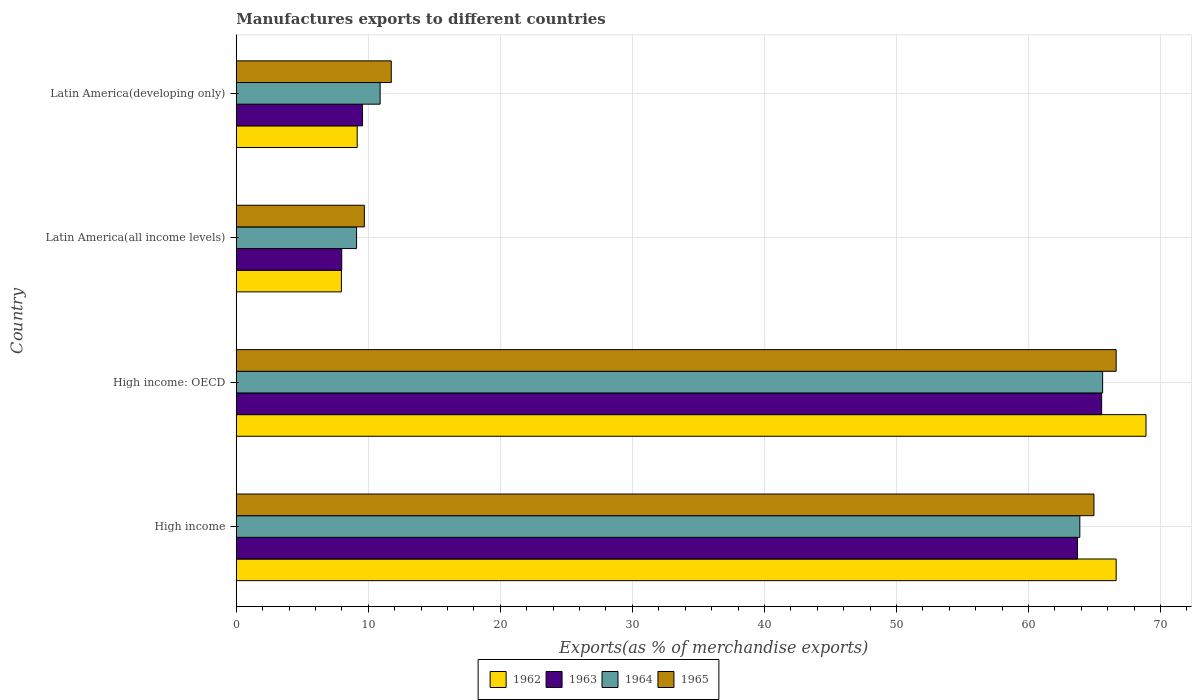How many different coloured bars are there?
Your answer should be very brief. 4. How many groups of bars are there?
Give a very brief answer. 4. How many bars are there on the 4th tick from the top?
Give a very brief answer. 4. How many bars are there on the 2nd tick from the bottom?
Keep it short and to the point. 4. What is the label of the 3rd group of bars from the top?
Provide a succinct answer. High income: OECD. In how many cases, is the number of bars for a given country not equal to the number of legend labels?
Offer a very short reply. 0. What is the percentage of exports to different countries in 1965 in Latin America(all income levels)?
Provide a succinct answer. 9.7. Across all countries, what is the maximum percentage of exports to different countries in 1962?
Provide a succinct answer. 68.9. Across all countries, what is the minimum percentage of exports to different countries in 1965?
Keep it short and to the point. 9.7. In which country was the percentage of exports to different countries in 1965 maximum?
Provide a succinct answer. High income: OECD. In which country was the percentage of exports to different countries in 1963 minimum?
Provide a short and direct response. Latin America(all income levels). What is the total percentage of exports to different countries in 1964 in the graph?
Provide a short and direct response. 149.51. What is the difference between the percentage of exports to different countries in 1962 in High income: OECD and that in Latin America(all income levels)?
Keep it short and to the point. 60.93. What is the difference between the percentage of exports to different countries in 1962 in Latin America(all income levels) and the percentage of exports to different countries in 1963 in High income: OECD?
Make the answer very short. -57.57. What is the average percentage of exports to different countries in 1964 per country?
Give a very brief answer. 37.38. What is the difference between the percentage of exports to different countries in 1964 and percentage of exports to different countries in 1965 in Latin America(all income levels)?
Your answer should be compact. -0.59. What is the ratio of the percentage of exports to different countries in 1965 in Latin America(all income levels) to that in Latin America(developing only)?
Make the answer very short. 0.83. What is the difference between the highest and the second highest percentage of exports to different countries in 1964?
Give a very brief answer. 1.73. What is the difference between the highest and the lowest percentage of exports to different countries in 1962?
Provide a succinct answer. 60.93. In how many countries, is the percentage of exports to different countries in 1964 greater than the average percentage of exports to different countries in 1964 taken over all countries?
Your answer should be very brief. 2. Is the sum of the percentage of exports to different countries in 1964 in High income and Latin America(all income levels) greater than the maximum percentage of exports to different countries in 1965 across all countries?
Provide a succinct answer. Yes. Is it the case that in every country, the sum of the percentage of exports to different countries in 1964 and percentage of exports to different countries in 1963 is greater than the sum of percentage of exports to different countries in 1962 and percentage of exports to different countries in 1965?
Provide a succinct answer. No. What does the 2nd bar from the top in High income: OECD represents?
Offer a very short reply. 1964. What does the 2nd bar from the bottom in High income: OECD represents?
Your response must be concise. 1963. How many countries are there in the graph?
Make the answer very short. 4. Are the values on the major ticks of X-axis written in scientific E-notation?
Provide a short and direct response. No. How many legend labels are there?
Keep it short and to the point. 4. What is the title of the graph?
Offer a terse response. Manufactures exports to different countries. Does "2000" appear as one of the legend labels in the graph?
Your response must be concise. No. What is the label or title of the X-axis?
Your answer should be compact. Exports(as % of merchandise exports). What is the Exports(as % of merchandise exports) of 1962 in High income?
Offer a terse response. 66.64. What is the Exports(as % of merchandise exports) in 1963 in High income?
Your answer should be compact. 63.71. What is the Exports(as % of merchandise exports) in 1964 in High income?
Ensure brevity in your answer.  63.89. What is the Exports(as % of merchandise exports) in 1965 in High income?
Your answer should be compact. 64.96. What is the Exports(as % of merchandise exports) of 1962 in High income: OECD?
Your response must be concise. 68.9. What is the Exports(as % of merchandise exports) in 1963 in High income: OECD?
Your answer should be compact. 65.54. What is the Exports(as % of merchandise exports) of 1964 in High income: OECD?
Offer a very short reply. 65.61. What is the Exports(as % of merchandise exports) in 1965 in High income: OECD?
Offer a terse response. 66.64. What is the Exports(as % of merchandise exports) of 1962 in Latin America(all income levels)?
Your answer should be very brief. 7.96. What is the Exports(as % of merchandise exports) of 1963 in Latin America(all income levels)?
Make the answer very short. 7.99. What is the Exports(as % of merchandise exports) in 1964 in Latin America(all income levels)?
Your response must be concise. 9.11. What is the Exports(as % of merchandise exports) of 1965 in Latin America(all income levels)?
Give a very brief answer. 9.7. What is the Exports(as % of merchandise exports) of 1962 in Latin America(developing only)?
Provide a succinct answer. 9.16. What is the Exports(as % of merchandise exports) in 1963 in Latin America(developing only)?
Ensure brevity in your answer.  9.56. What is the Exports(as % of merchandise exports) in 1964 in Latin America(developing only)?
Offer a terse response. 10.9. What is the Exports(as % of merchandise exports) in 1965 in Latin America(developing only)?
Give a very brief answer. 11.74. Across all countries, what is the maximum Exports(as % of merchandise exports) of 1962?
Keep it short and to the point. 68.9. Across all countries, what is the maximum Exports(as % of merchandise exports) in 1963?
Give a very brief answer. 65.54. Across all countries, what is the maximum Exports(as % of merchandise exports) in 1964?
Your answer should be compact. 65.61. Across all countries, what is the maximum Exports(as % of merchandise exports) in 1965?
Your answer should be compact. 66.64. Across all countries, what is the minimum Exports(as % of merchandise exports) of 1962?
Your response must be concise. 7.96. Across all countries, what is the minimum Exports(as % of merchandise exports) in 1963?
Keep it short and to the point. 7.99. Across all countries, what is the minimum Exports(as % of merchandise exports) in 1964?
Your answer should be very brief. 9.11. Across all countries, what is the minimum Exports(as % of merchandise exports) of 1965?
Your response must be concise. 9.7. What is the total Exports(as % of merchandise exports) of 1962 in the graph?
Your response must be concise. 152.66. What is the total Exports(as % of merchandise exports) in 1963 in the graph?
Keep it short and to the point. 146.8. What is the total Exports(as % of merchandise exports) in 1964 in the graph?
Keep it short and to the point. 149.51. What is the total Exports(as % of merchandise exports) in 1965 in the graph?
Offer a very short reply. 153.03. What is the difference between the Exports(as % of merchandise exports) of 1962 in High income and that in High income: OECD?
Offer a terse response. -2.26. What is the difference between the Exports(as % of merchandise exports) in 1963 in High income and that in High income: OECD?
Your answer should be compact. -1.83. What is the difference between the Exports(as % of merchandise exports) in 1964 in High income and that in High income: OECD?
Offer a very short reply. -1.73. What is the difference between the Exports(as % of merchandise exports) of 1965 in High income and that in High income: OECD?
Ensure brevity in your answer.  -1.68. What is the difference between the Exports(as % of merchandise exports) of 1962 in High income and that in Latin America(all income levels)?
Provide a succinct answer. 58.68. What is the difference between the Exports(as % of merchandise exports) in 1963 in High income and that in Latin America(all income levels)?
Ensure brevity in your answer.  55.72. What is the difference between the Exports(as % of merchandise exports) in 1964 in High income and that in Latin America(all income levels)?
Your response must be concise. 54.78. What is the difference between the Exports(as % of merchandise exports) in 1965 in High income and that in Latin America(all income levels)?
Your answer should be very brief. 55.25. What is the difference between the Exports(as % of merchandise exports) in 1962 in High income and that in Latin America(developing only)?
Offer a terse response. 57.48. What is the difference between the Exports(as % of merchandise exports) in 1963 in High income and that in Latin America(developing only)?
Offer a terse response. 54.15. What is the difference between the Exports(as % of merchandise exports) in 1964 in High income and that in Latin America(developing only)?
Offer a very short reply. 52.99. What is the difference between the Exports(as % of merchandise exports) in 1965 in High income and that in Latin America(developing only)?
Your response must be concise. 53.22. What is the difference between the Exports(as % of merchandise exports) of 1962 in High income: OECD and that in Latin America(all income levels)?
Provide a succinct answer. 60.93. What is the difference between the Exports(as % of merchandise exports) of 1963 in High income: OECD and that in Latin America(all income levels)?
Ensure brevity in your answer.  57.55. What is the difference between the Exports(as % of merchandise exports) of 1964 in High income: OECD and that in Latin America(all income levels)?
Give a very brief answer. 56.5. What is the difference between the Exports(as % of merchandise exports) of 1965 in High income: OECD and that in Latin America(all income levels)?
Your answer should be very brief. 56.94. What is the difference between the Exports(as % of merchandise exports) of 1962 in High income: OECD and that in Latin America(developing only)?
Provide a succinct answer. 59.74. What is the difference between the Exports(as % of merchandise exports) in 1963 in High income: OECD and that in Latin America(developing only)?
Offer a very short reply. 55.98. What is the difference between the Exports(as % of merchandise exports) of 1964 in High income: OECD and that in Latin America(developing only)?
Provide a succinct answer. 54.72. What is the difference between the Exports(as % of merchandise exports) in 1965 in High income: OECD and that in Latin America(developing only)?
Your answer should be compact. 54.9. What is the difference between the Exports(as % of merchandise exports) of 1962 in Latin America(all income levels) and that in Latin America(developing only)?
Keep it short and to the point. -1.2. What is the difference between the Exports(as % of merchandise exports) in 1963 in Latin America(all income levels) and that in Latin America(developing only)?
Your response must be concise. -1.57. What is the difference between the Exports(as % of merchandise exports) of 1964 in Latin America(all income levels) and that in Latin America(developing only)?
Provide a succinct answer. -1.78. What is the difference between the Exports(as % of merchandise exports) of 1965 in Latin America(all income levels) and that in Latin America(developing only)?
Your response must be concise. -2.04. What is the difference between the Exports(as % of merchandise exports) of 1962 in High income and the Exports(as % of merchandise exports) of 1963 in High income: OECD?
Provide a short and direct response. 1.1. What is the difference between the Exports(as % of merchandise exports) in 1962 in High income and the Exports(as % of merchandise exports) in 1964 in High income: OECD?
Give a very brief answer. 1.03. What is the difference between the Exports(as % of merchandise exports) of 1962 in High income and the Exports(as % of merchandise exports) of 1965 in High income: OECD?
Your response must be concise. 0. What is the difference between the Exports(as % of merchandise exports) in 1963 in High income and the Exports(as % of merchandise exports) in 1964 in High income: OECD?
Your answer should be very brief. -1.91. What is the difference between the Exports(as % of merchandise exports) of 1963 in High income and the Exports(as % of merchandise exports) of 1965 in High income: OECD?
Your response must be concise. -2.93. What is the difference between the Exports(as % of merchandise exports) in 1964 in High income and the Exports(as % of merchandise exports) in 1965 in High income: OECD?
Keep it short and to the point. -2.75. What is the difference between the Exports(as % of merchandise exports) of 1962 in High income and the Exports(as % of merchandise exports) of 1963 in Latin America(all income levels)?
Your answer should be very brief. 58.65. What is the difference between the Exports(as % of merchandise exports) of 1962 in High income and the Exports(as % of merchandise exports) of 1964 in Latin America(all income levels)?
Your response must be concise. 57.53. What is the difference between the Exports(as % of merchandise exports) in 1962 in High income and the Exports(as % of merchandise exports) in 1965 in Latin America(all income levels)?
Your answer should be very brief. 56.94. What is the difference between the Exports(as % of merchandise exports) of 1963 in High income and the Exports(as % of merchandise exports) of 1964 in Latin America(all income levels)?
Provide a succinct answer. 54.6. What is the difference between the Exports(as % of merchandise exports) in 1963 in High income and the Exports(as % of merchandise exports) in 1965 in Latin America(all income levels)?
Give a very brief answer. 54.01. What is the difference between the Exports(as % of merchandise exports) of 1964 in High income and the Exports(as % of merchandise exports) of 1965 in Latin America(all income levels)?
Offer a very short reply. 54.19. What is the difference between the Exports(as % of merchandise exports) of 1962 in High income and the Exports(as % of merchandise exports) of 1963 in Latin America(developing only)?
Make the answer very short. 57.08. What is the difference between the Exports(as % of merchandise exports) of 1962 in High income and the Exports(as % of merchandise exports) of 1964 in Latin America(developing only)?
Your answer should be compact. 55.74. What is the difference between the Exports(as % of merchandise exports) in 1962 in High income and the Exports(as % of merchandise exports) in 1965 in Latin America(developing only)?
Provide a succinct answer. 54.9. What is the difference between the Exports(as % of merchandise exports) in 1963 in High income and the Exports(as % of merchandise exports) in 1964 in Latin America(developing only)?
Keep it short and to the point. 52.81. What is the difference between the Exports(as % of merchandise exports) of 1963 in High income and the Exports(as % of merchandise exports) of 1965 in Latin America(developing only)?
Provide a short and direct response. 51.97. What is the difference between the Exports(as % of merchandise exports) of 1964 in High income and the Exports(as % of merchandise exports) of 1965 in Latin America(developing only)?
Provide a succinct answer. 52.15. What is the difference between the Exports(as % of merchandise exports) of 1962 in High income: OECD and the Exports(as % of merchandise exports) of 1963 in Latin America(all income levels)?
Your response must be concise. 60.91. What is the difference between the Exports(as % of merchandise exports) of 1962 in High income: OECD and the Exports(as % of merchandise exports) of 1964 in Latin America(all income levels)?
Your answer should be compact. 59.79. What is the difference between the Exports(as % of merchandise exports) in 1962 in High income: OECD and the Exports(as % of merchandise exports) in 1965 in Latin America(all income levels)?
Your answer should be very brief. 59.2. What is the difference between the Exports(as % of merchandise exports) in 1963 in High income: OECD and the Exports(as % of merchandise exports) in 1964 in Latin America(all income levels)?
Keep it short and to the point. 56.43. What is the difference between the Exports(as % of merchandise exports) of 1963 in High income: OECD and the Exports(as % of merchandise exports) of 1965 in Latin America(all income levels)?
Offer a terse response. 55.84. What is the difference between the Exports(as % of merchandise exports) of 1964 in High income: OECD and the Exports(as % of merchandise exports) of 1965 in Latin America(all income levels)?
Your answer should be compact. 55.91. What is the difference between the Exports(as % of merchandise exports) of 1962 in High income: OECD and the Exports(as % of merchandise exports) of 1963 in Latin America(developing only)?
Make the answer very short. 59.34. What is the difference between the Exports(as % of merchandise exports) of 1962 in High income: OECD and the Exports(as % of merchandise exports) of 1964 in Latin America(developing only)?
Offer a very short reply. 58. What is the difference between the Exports(as % of merchandise exports) of 1962 in High income: OECD and the Exports(as % of merchandise exports) of 1965 in Latin America(developing only)?
Offer a very short reply. 57.16. What is the difference between the Exports(as % of merchandise exports) of 1963 in High income: OECD and the Exports(as % of merchandise exports) of 1964 in Latin America(developing only)?
Your answer should be compact. 54.64. What is the difference between the Exports(as % of merchandise exports) in 1963 in High income: OECD and the Exports(as % of merchandise exports) in 1965 in Latin America(developing only)?
Ensure brevity in your answer.  53.8. What is the difference between the Exports(as % of merchandise exports) in 1964 in High income: OECD and the Exports(as % of merchandise exports) in 1965 in Latin America(developing only)?
Offer a very short reply. 53.87. What is the difference between the Exports(as % of merchandise exports) of 1962 in Latin America(all income levels) and the Exports(as % of merchandise exports) of 1963 in Latin America(developing only)?
Offer a terse response. -1.6. What is the difference between the Exports(as % of merchandise exports) in 1962 in Latin America(all income levels) and the Exports(as % of merchandise exports) in 1964 in Latin America(developing only)?
Ensure brevity in your answer.  -2.93. What is the difference between the Exports(as % of merchandise exports) of 1962 in Latin America(all income levels) and the Exports(as % of merchandise exports) of 1965 in Latin America(developing only)?
Ensure brevity in your answer.  -3.78. What is the difference between the Exports(as % of merchandise exports) of 1963 in Latin America(all income levels) and the Exports(as % of merchandise exports) of 1964 in Latin America(developing only)?
Give a very brief answer. -2.91. What is the difference between the Exports(as % of merchandise exports) in 1963 in Latin America(all income levels) and the Exports(as % of merchandise exports) in 1965 in Latin America(developing only)?
Make the answer very short. -3.75. What is the difference between the Exports(as % of merchandise exports) in 1964 in Latin America(all income levels) and the Exports(as % of merchandise exports) in 1965 in Latin America(developing only)?
Make the answer very short. -2.63. What is the average Exports(as % of merchandise exports) in 1962 per country?
Offer a very short reply. 38.17. What is the average Exports(as % of merchandise exports) of 1963 per country?
Give a very brief answer. 36.7. What is the average Exports(as % of merchandise exports) in 1964 per country?
Ensure brevity in your answer.  37.38. What is the average Exports(as % of merchandise exports) of 1965 per country?
Make the answer very short. 38.26. What is the difference between the Exports(as % of merchandise exports) in 1962 and Exports(as % of merchandise exports) in 1963 in High income?
Your answer should be very brief. 2.93. What is the difference between the Exports(as % of merchandise exports) in 1962 and Exports(as % of merchandise exports) in 1964 in High income?
Provide a succinct answer. 2.75. What is the difference between the Exports(as % of merchandise exports) of 1962 and Exports(as % of merchandise exports) of 1965 in High income?
Your answer should be very brief. 1.68. What is the difference between the Exports(as % of merchandise exports) in 1963 and Exports(as % of merchandise exports) in 1964 in High income?
Give a very brief answer. -0.18. What is the difference between the Exports(as % of merchandise exports) of 1963 and Exports(as % of merchandise exports) of 1965 in High income?
Your answer should be compact. -1.25. What is the difference between the Exports(as % of merchandise exports) in 1964 and Exports(as % of merchandise exports) in 1965 in High income?
Offer a very short reply. -1.07. What is the difference between the Exports(as % of merchandise exports) in 1962 and Exports(as % of merchandise exports) in 1963 in High income: OECD?
Ensure brevity in your answer.  3.36. What is the difference between the Exports(as % of merchandise exports) of 1962 and Exports(as % of merchandise exports) of 1964 in High income: OECD?
Ensure brevity in your answer.  3.28. What is the difference between the Exports(as % of merchandise exports) in 1962 and Exports(as % of merchandise exports) in 1965 in High income: OECD?
Ensure brevity in your answer.  2.26. What is the difference between the Exports(as % of merchandise exports) in 1963 and Exports(as % of merchandise exports) in 1964 in High income: OECD?
Your answer should be very brief. -0.08. What is the difference between the Exports(as % of merchandise exports) of 1963 and Exports(as % of merchandise exports) of 1965 in High income: OECD?
Make the answer very short. -1.1. What is the difference between the Exports(as % of merchandise exports) in 1964 and Exports(as % of merchandise exports) in 1965 in High income: OECD?
Your answer should be very brief. -1.02. What is the difference between the Exports(as % of merchandise exports) of 1962 and Exports(as % of merchandise exports) of 1963 in Latin America(all income levels)?
Your answer should be compact. -0.02. What is the difference between the Exports(as % of merchandise exports) in 1962 and Exports(as % of merchandise exports) in 1964 in Latin America(all income levels)?
Provide a short and direct response. -1.15. What is the difference between the Exports(as % of merchandise exports) of 1962 and Exports(as % of merchandise exports) of 1965 in Latin America(all income levels)?
Your answer should be very brief. -1.74. What is the difference between the Exports(as % of merchandise exports) in 1963 and Exports(as % of merchandise exports) in 1964 in Latin America(all income levels)?
Offer a terse response. -1.12. What is the difference between the Exports(as % of merchandise exports) in 1963 and Exports(as % of merchandise exports) in 1965 in Latin America(all income levels)?
Offer a terse response. -1.71. What is the difference between the Exports(as % of merchandise exports) in 1964 and Exports(as % of merchandise exports) in 1965 in Latin America(all income levels)?
Offer a very short reply. -0.59. What is the difference between the Exports(as % of merchandise exports) of 1962 and Exports(as % of merchandise exports) of 1963 in Latin America(developing only)?
Offer a terse response. -0.4. What is the difference between the Exports(as % of merchandise exports) of 1962 and Exports(as % of merchandise exports) of 1964 in Latin America(developing only)?
Ensure brevity in your answer.  -1.74. What is the difference between the Exports(as % of merchandise exports) of 1962 and Exports(as % of merchandise exports) of 1965 in Latin America(developing only)?
Provide a succinct answer. -2.58. What is the difference between the Exports(as % of merchandise exports) of 1963 and Exports(as % of merchandise exports) of 1964 in Latin America(developing only)?
Your response must be concise. -1.33. What is the difference between the Exports(as % of merchandise exports) of 1963 and Exports(as % of merchandise exports) of 1965 in Latin America(developing only)?
Your answer should be compact. -2.18. What is the difference between the Exports(as % of merchandise exports) of 1964 and Exports(as % of merchandise exports) of 1965 in Latin America(developing only)?
Offer a terse response. -0.84. What is the ratio of the Exports(as % of merchandise exports) of 1962 in High income to that in High income: OECD?
Ensure brevity in your answer.  0.97. What is the ratio of the Exports(as % of merchandise exports) of 1963 in High income to that in High income: OECD?
Offer a terse response. 0.97. What is the ratio of the Exports(as % of merchandise exports) in 1964 in High income to that in High income: OECD?
Make the answer very short. 0.97. What is the ratio of the Exports(as % of merchandise exports) in 1965 in High income to that in High income: OECD?
Ensure brevity in your answer.  0.97. What is the ratio of the Exports(as % of merchandise exports) in 1962 in High income to that in Latin America(all income levels)?
Your answer should be compact. 8.37. What is the ratio of the Exports(as % of merchandise exports) in 1963 in High income to that in Latin America(all income levels)?
Offer a terse response. 7.97. What is the ratio of the Exports(as % of merchandise exports) in 1964 in High income to that in Latin America(all income levels)?
Your answer should be compact. 7.01. What is the ratio of the Exports(as % of merchandise exports) of 1965 in High income to that in Latin America(all income levels)?
Offer a terse response. 6.7. What is the ratio of the Exports(as % of merchandise exports) of 1962 in High income to that in Latin America(developing only)?
Provide a succinct answer. 7.28. What is the ratio of the Exports(as % of merchandise exports) in 1963 in High income to that in Latin America(developing only)?
Ensure brevity in your answer.  6.66. What is the ratio of the Exports(as % of merchandise exports) of 1964 in High income to that in Latin America(developing only)?
Your answer should be compact. 5.86. What is the ratio of the Exports(as % of merchandise exports) of 1965 in High income to that in Latin America(developing only)?
Offer a terse response. 5.53. What is the ratio of the Exports(as % of merchandise exports) in 1962 in High income: OECD to that in Latin America(all income levels)?
Ensure brevity in your answer.  8.65. What is the ratio of the Exports(as % of merchandise exports) in 1963 in High income: OECD to that in Latin America(all income levels)?
Make the answer very short. 8.2. What is the ratio of the Exports(as % of merchandise exports) of 1964 in High income: OECD to that in Latin America(all income levels)?
Your response must be concise. 7.2. What is the ratio of the Exports(as % of merchandise exports) in 1965 in High income: OECD to that in Latin America(all income levels)?
Give a very brief answer. 6.87. What is the ratio of the Exports(as % of merchandise exports) in 1962 in High income: OECD to that in Latin America(developing only)?
Your answer should be very brief. 7.52. What is the ratio of the Exports(as % of merchandise exports) of 1963 in High income: OECD to that in Latin America(developing only)?
Keep it short and to the point. 6.85. What is the ratio of the Exports(as % of merchandise exports) in 1964 in High income: OECD to that in Latin America(developing only)?
Offer a terse response. 6.02. What is the ratio of the Exports(as % of merchandise exports) of 1965 in High income: OECD to that in Latin America(developing only)?
Provide a succinct answer. 5.68. What is the ratio of the Exports(as % of merchandise exports) in 1962 in Latin America(all income levels) to that in Latin America(developing only)?
Your answer should be very brief. 0.87. What is the ratio of the Exports(as % of merchandise exports) in 1963 in Latin America(all income levels) to that in Latin America(developing only)?
Give a very brief answer. 0.84. What is the ratio of the Exports(as % of merchandise exports) of 1964 in Latin America(all income levels) to that in Latin America(developing only)?
Make the answer very short. 0.84. What is the ratio of the Exports(as % of merchandise exports) in 1965 in Latin America(all income levels) to that in Latin America(developing only)?
Offer a terse response. 0.83. What is the difference between the highest and the second highest Exports(as % of merchandise exports) of 1962?
Make the answer very short. 2.26. What is the difference between the highest and the second highest Exports(as % of merchandise exports) of 1963?
Keep it short and to the point. 1.83. What is the difference between the highest and the second highest Exports(as % of merchandise exports) in 1964?
Give a very brief answer. 1.73. What is the difference between the highest and the second highest Exports(as % of merchandise exports) of 1965?
Give a very brief answer. 1.68. What is the difference between the highest and the lowest Exports(as % of merchandise exports) of 1962?
Your response must be concise. 60.93. What is the difference between the highest and the lowest Exports(as % of merchandise exports) of 1963?
Keep it short and to the point. 57.55. What is the difference between the highest and the lowest Exports(as % of merchandise exports) in 1964?
Your answer should be compact. 56.5. What is the difference between the highest and the lowest Exports(as % of merchandise exports) of 1965?
Offer a terse response. 56.94. 